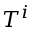Convert formula to latex. <formula><loc_0><loc_0><loc_500><loc_500>T ^ { i }</formula> 